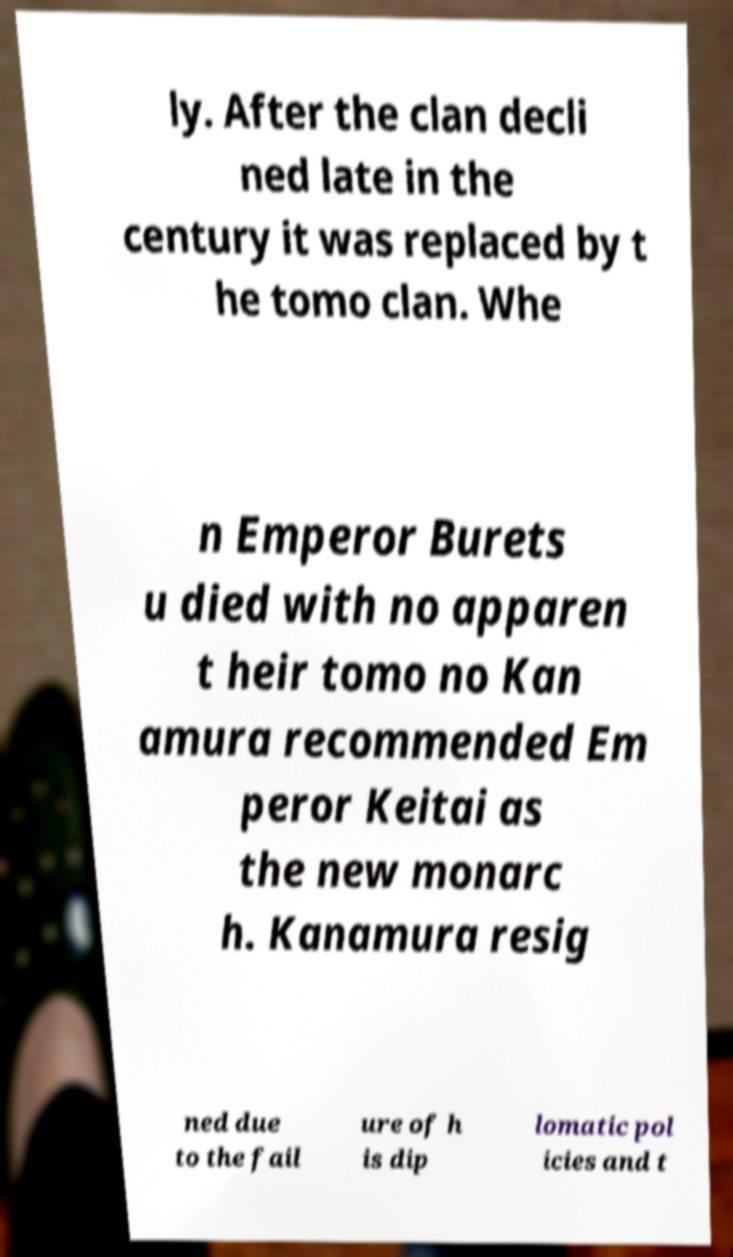Can you read and provide the text displayed in the image?This photo seems to have some interesting text. Can you extract and type it out for me? ly. After the clan decli ned late in the century it was replaced by t he tomo clan. Whe n Emperor Burets u died with no apparen t heir tomo no Kan amura recommended Em peror Keitai as the new monarc h. Kanamura resig ned due to the fail ure of h is dip lomatic pol icies and t 